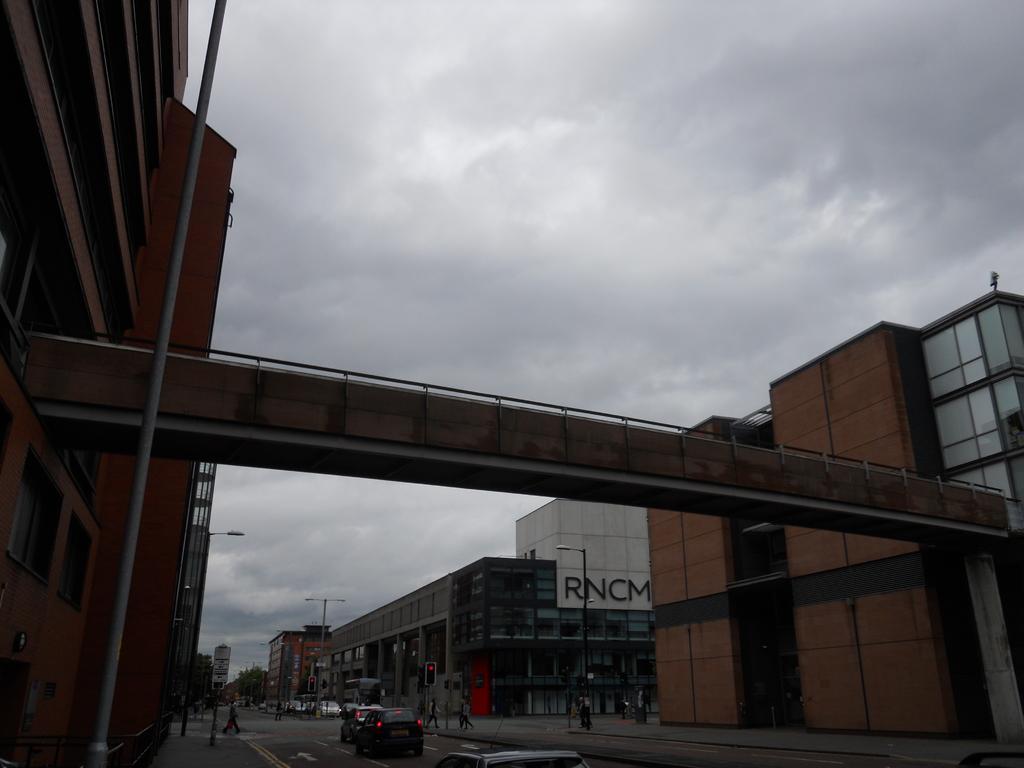Describe this image in one or two sentences. In this picture I can see buildings and few cars on the road and I can see few people walking and few pole lights and trees and I can see text on the wall of the building and I can see foot over bridge and a cloudy sky. 